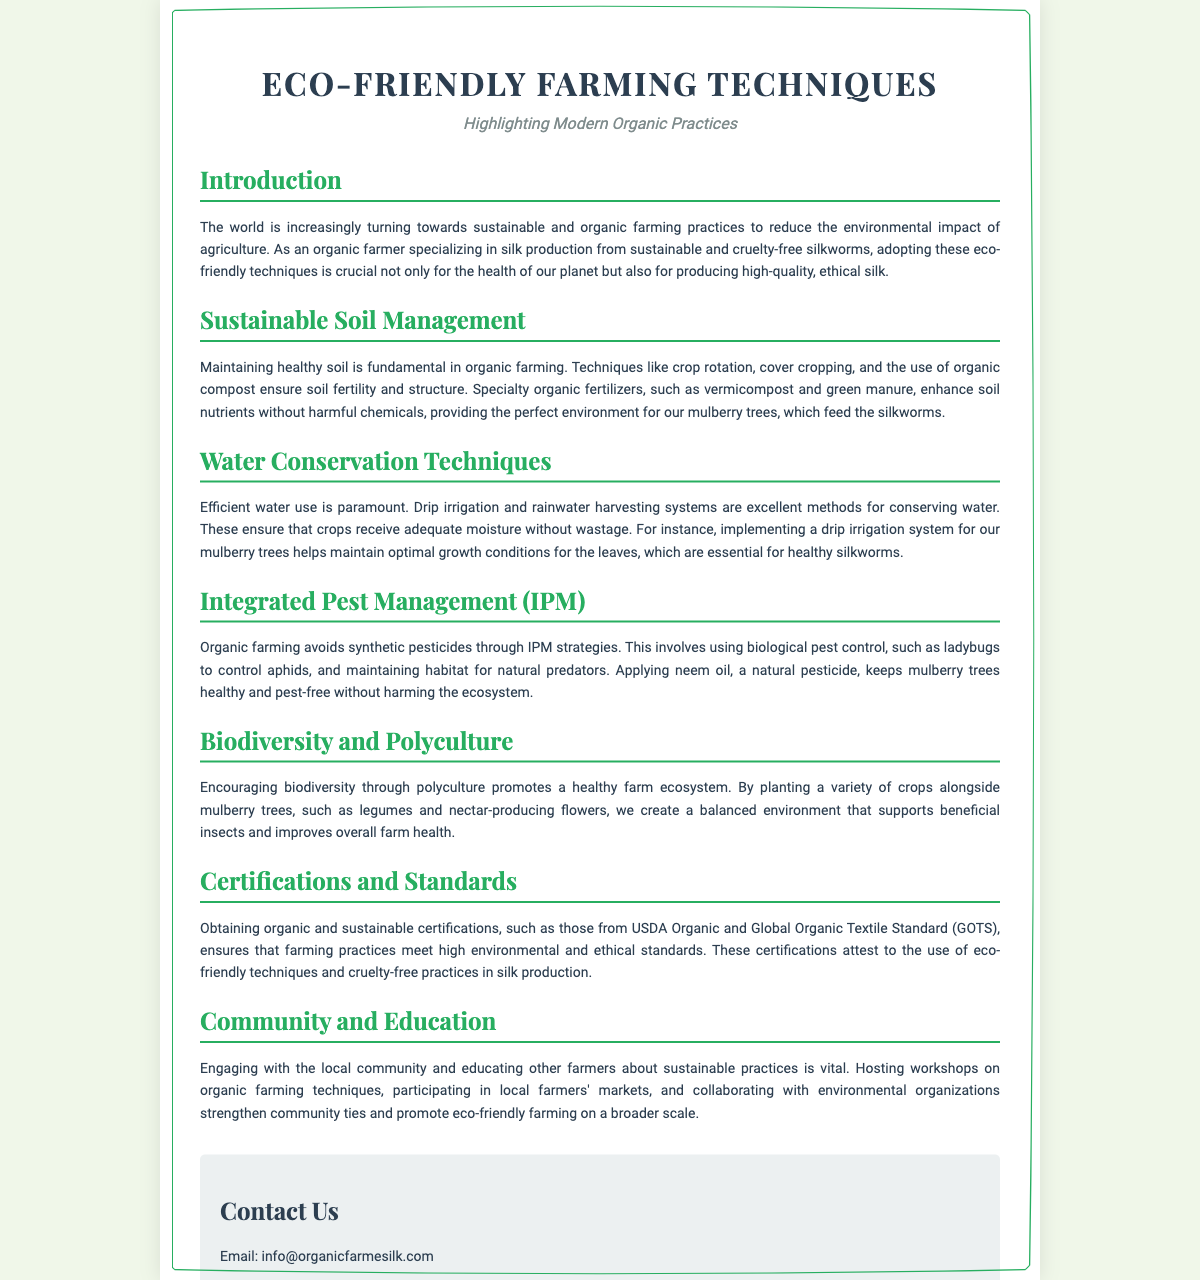What is the title of the document? The title of the document is found at the top of the Playbill, indicating the main theme or subject matter.
Answer: Eco-Friendly Farming Techniques What type of practices are highlighted in this document? The subtitle provides information on the focus of the practices discussed in the document.
Answer: Modern Organic Practices What is one key technique for sustainable soil management mentioned? The document lists several soil management techniques under the corresponding section.
Answer: Crop rotation What is a method for conserving water mentioned in the document? The section on water conservation techniques provides specific methods used in organic farming.
Answer: Drip irrigation What certification is mentioned in relation to organic practices? The certifications and standards section highlights important certifications for sustainable practices.
Answer: USDA Organic How does the document suggest promoting biodiversity? The section on biodiversity and polyculture describes methods to enhance farm ecosystems.
Answer: Polyculture Who is the intended audience for community engagement efforts mentioned? The document suggests engaging with local stakeholders, hinting at those involved in farming or agriculture.
Answer: Other farmers What natural pesticide is mentioned for use in integrated pest management? The document specifies a type of natural pesticide used for pest control in organic farming.
Answer: Neem oil What is the purpose of hosting workshops according to the document? The document explains the importance of education and community involvement in sustainable practices.
Answer: Educate other farmers 